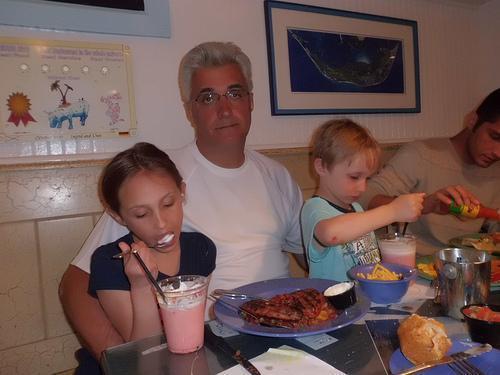How many people are wearing glasses in the image?
Give a very brief answer. 1. 